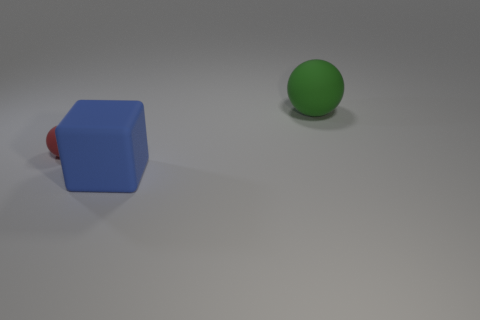Add 3 large blue blocks. How many objects exist? 6 Subtract all cubes. How many objects are left? 2 Add 3 rubber balls. How many rubber balls are left? 5 Add 2 large green rubber cylinders. How many large green rubber cylinders exist? 2 Subtract 1 red spheres. How many objects are left? 2 Subtract all matte blocks. Subtract all big blue rubber cubes. How many objects are left? 1 